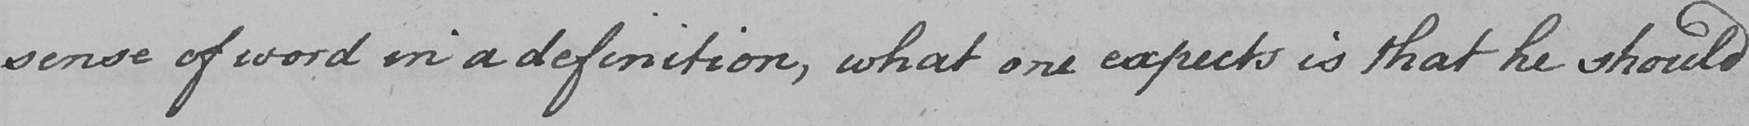Please provide the text content of this handwritten line. sense of word in a definition , what one expects is that he should 